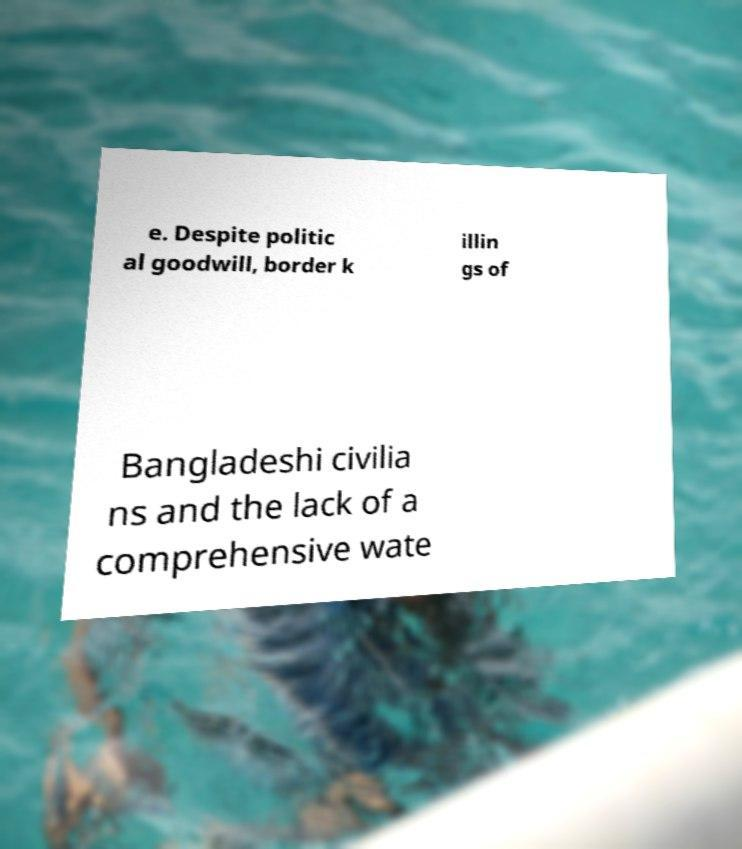Please identify and transcribe the text found in this image. e. Despite politic al goodwill, border k illin gs of Bangladeshi civilia ns and the lack of a comprehensive wate 